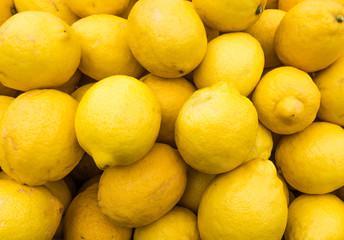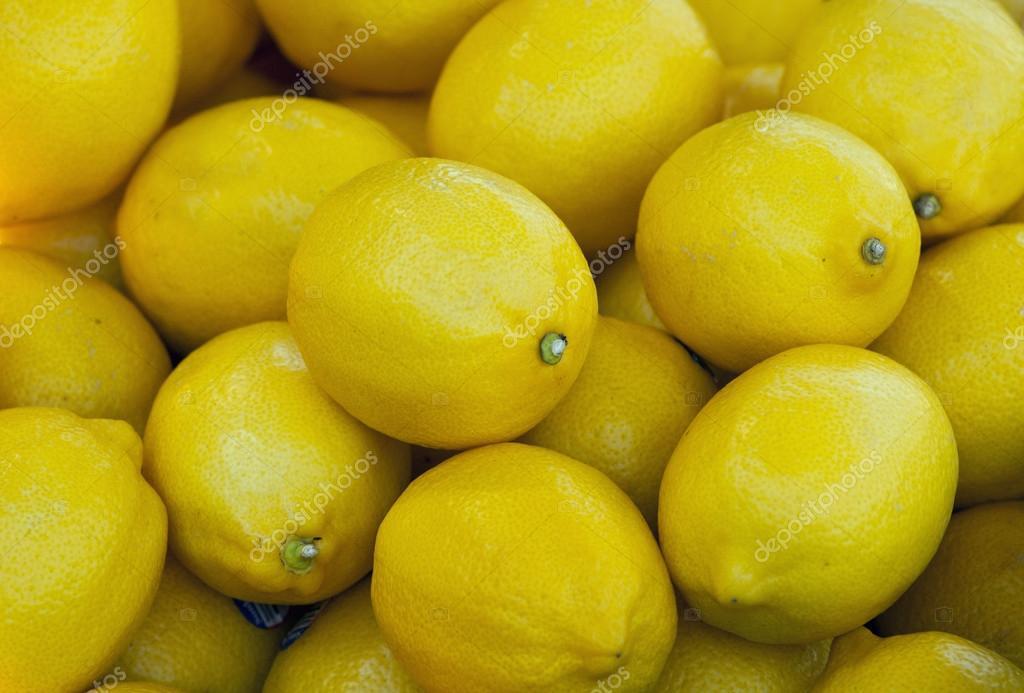The first image is the image on the left, the second image is the image on the right. Analyze the images presented: Is the assertion "In at least one iamge there is a group of lemons with a single lemon facing up and right forward." valid? Answer yes or no. No. 